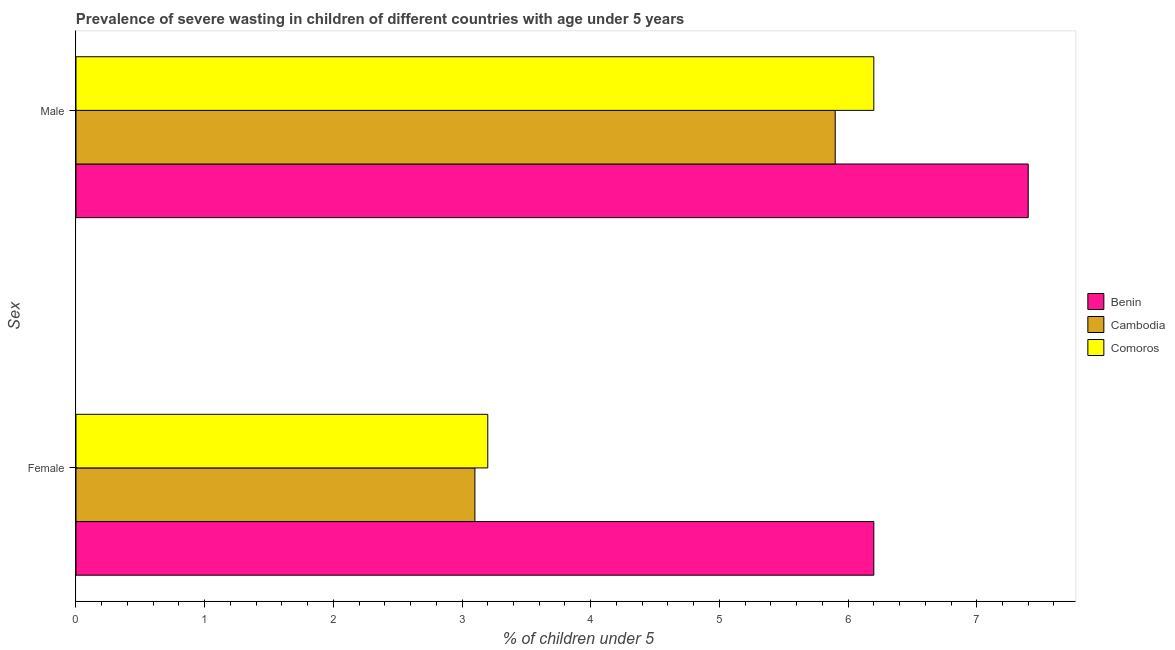How many different coloured bars are there?
Provide a short and direct response. 3. Are the number of bars per tick equal to the number of legend labels?
Ensure brevity in your answer.  Yes. How many bars are there on the 1st tick from the bottom?
Offer a very short reply. 3. What is the label of the 1st group of bars from the top?
Provide a short and direct response. Male. What is the percentage of undernourished male children in Comoros?
Make the answer very short. 6.2. Across all countries, what is the maximum percentage of undernourished female children?
Offer a very short reply. 6.2. Across all countries, what is the minimum percentage of undernourished female children?
Offer a terse response. 3.1. In which country was the percentage of undernourished female children maximum?
Keep it short and to the point. Benin. In which country was the percentage of undernourished male children minimum?
Ensure brevity in your answer.  Cambodia. What is the total percentage of undernourished female children in the graph?
Provide a succinct answer. 12.5. What is the difference between the percentage of undernourished female children in Cambodia and that in Benin?
Provide a short and direct response. -3.1. What is the difference between the percentage of undernourished female children in Cambodia and the percentage of undernourished male children in Comoros?
Keep it short and to the point. -3.1. What is the average percentage of undernourished male children per country?
Your response must be concise. 6.5. What is the difference between the percentage of undernourished female children and percentage of undernourished male children in Comoros?
Your response must be concise. -3. What is the ratio of the percentage of undernourished male children in Comoros to that in Benin?
Give a very brief answer. 0.84. Is the percentage of undernourished female children in Comoros less than that in Cambodia?
Provide a succinct answer. No. What does the 3rd bar from the top in Female represents?
Offer a terse response. Benin. What does the 3rd bar from the bottom in Male represents?
Your answer should be very brief. Comoros. Are all the bars in the graph horizontal?
Keep it short and to the point. Yes. How many countries are there in the graph?
Give a very brief answer. 3. What is the difference between two consecutive major ticks on the X-axis?
Your answer should be very brief. 1. Does the graph contain grids?
Keep it short and to the point. No. Where does the legend appear in the graph?
Offer a very short reply. Center right. How are the legend labels stacked?
Offer a very short reply. Vertical. What is the title of the graph?
Provide a succinct answer. Prevalence of severe wasting in children of different countries with age under 5 years. What is the label or title of the X-axis?
Offer a terse response.  % of children under 5. What is the label or title of the Y-axis?
Give a very brief answer. Sex. What is the  % of children under 5 of Benin in Female?
Your answer should be compact. 6.2. What is the  % of children under 5 of Cambodia in Female?
Your response must be concise. 3.1. What is the  % of children under 5 of Comoros in Female?
Provide a short and direct response. 3.2. What is the  % of children under 5 in Benin in Male?
Ensure brevity in your answer.  7.4. What is the  % of children under 5 in Cambodia in Male?
Offer a very short reply. 5.9. What is the  % of children under 5 in Comoros in Male?
Your answer should be compact. 6.2. Across all Sex, what is the maximum  % of children under 5 in Benin?
Keep it short and to the point. 7.4. Across all Sex, what is the maximum  % of children under 5 in Cambodia?
Your response must be concise. 5.9. Across all Sex, what is the maximum  % of children under 5 of Comoros?
Your answer should be compact. 6.2. Across all Sex, what is the minimum  % of children under 5 of Benin?
Your answer should be compact. 6.2. Across all Sex, what is the minimum  % of children under 5 in Cambodia?
Ensure brevity in your answer.  3.1. Across all Sex, what is the minimum  % of children under 5 of Comoros?
Give a very brief answer. 3.2. What is the total  % of children under 5 of Cambodia in the graph?
Make the answer very short. 9. What is the total  % of children under 5 of Comoros in the graph?
Your answer should be compact. 9.4. What is the difference between the  % of children under 5 of Comoros in Female and that in Male?
Offer a terse response. -3. What is the average  % of children under 5 of Benin per Sex?
Your response must be concise. 6.8. What is the average  % of children under 5 of Cambodia per Sex?
Make the answer very short. 4.5. What is the difference between the  % of children under 5 in Benin and  % of children under 5 in Comoros in Female?
Provide a short and direct response. 3. What is the difference between the  % of children under 5 in Benin and  % of children under 5 in Cambodia in Male?
Offer a very short reply. 1.5. What is the difference between the  % of children under 5 in Benin and  % of children under 5 in Comoros in Male?
Provide a short and direct response. 1.2. What is the ratio of the  % of children under 5 of Benin in Female to that in Male?
Give a very brief answer. 0.84. What is the ratio of the  % of children under 5 in Cambodia in Female to that in Male?
Your response must be concise. 0.53. What is the ratio of the  % of children under 5 in Comoros in Female to that in Male?
Ensure brevity in your answer.  0.52. What is the difference between the highest and the second highest  % of children under 5 in Benin?
Make the answer very short. 1.2. What is the difference between the highest and the second highest  % of children under 5 of Cambodia?
Your response must be concise. 2.8. What is the difference between the highest and the lowest  % of children under 5 of Benin?
Provide a short and direct response. 1.2. What is the difference between the highest and the lowest  % of children under 5 of Comoros?
Your answer should be compact. 3. 